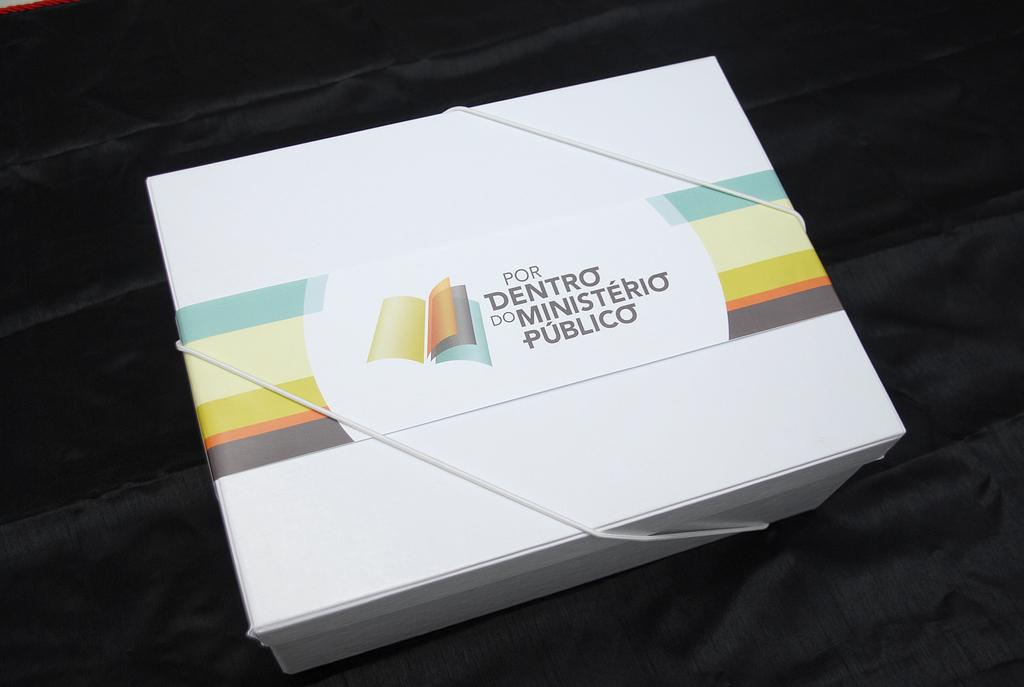Provide a one-sentence caption for the provided image. A white box that says Por Dentro Do Ministerio Publico. 